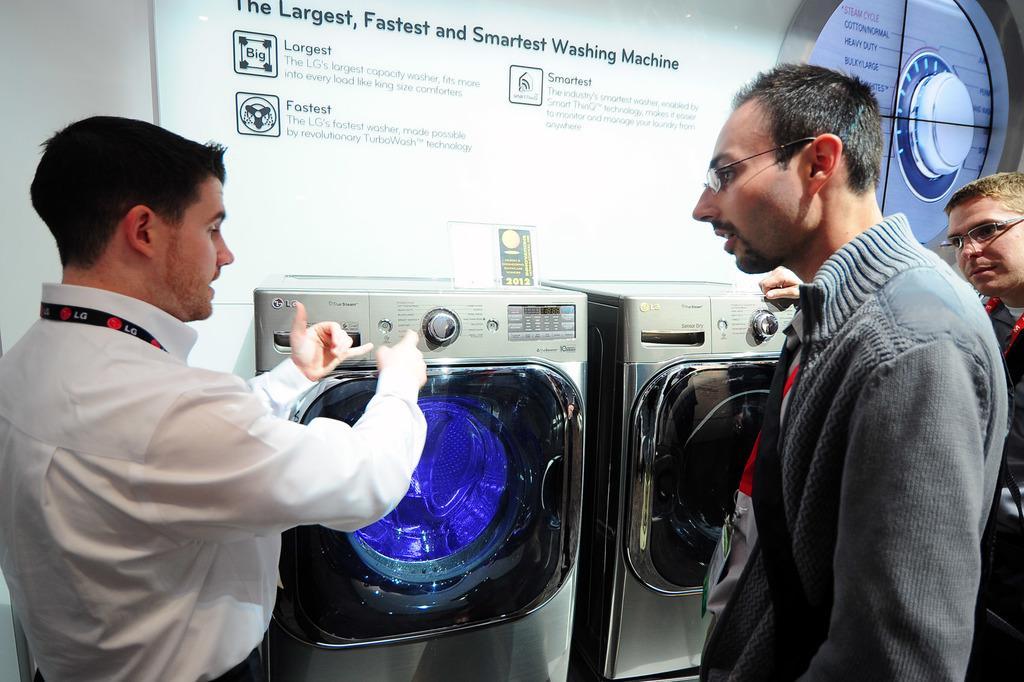How would you summarize this image in a sentence or two? In this image we can see there are persons standing. At the back there is a washing machine. And there is a wall, to the wall there is a screen with text and logo. 